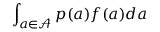<formula> <loc_0><loc_0><loc_500><loc_500>\int _ { a \in \mathcal { A } } p ( a ) f ( a ) d a</formula> 